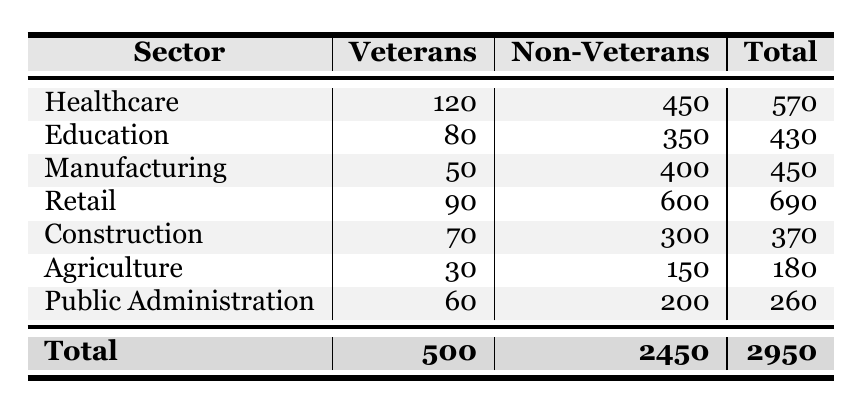What sector has the highest number of veterans employed? According to the table, the sector with the highest number of veterans employed is Healthcare, with 120 veterans employed.
Answer: Healthcare How many total employees (veterans and non-veterans) are there in the Retail sector? The Retail sector has 90 veterans employed and 600 non-veterans employed. Adding these gives a total of 90 + 600 = 690 employees.
Answer: 690 Is there a greater number of non-veterans employed in Agriculture than in Construction? In Agriculture, there are 150 non-veterans employed, while in Construction, there are 300 non-veterans. Since 150 is less than 300, the statement is false.
Answer: No What is the total number of veterans employed across all sectors? To find the total number of veterans employed, sum all the veterans employed in each sector: 120 + 80 + 50 + 90 + 70 + 30 + 60 = 500.
Answer: 500 Which sector has the smallest number of veterans employed, and how many are there? Looking through the table, the Agriculture sector has the smallest number of veterans employed, which is 30.
Answer: Agriculture, 30 What is the average number of veterans employed per sector? There are 7 sectors, and the total number of veterans employed is 500. To find the average, divide the total by the number of sectors: 500 / 7 ≈ 71.43.
Answer: 71.43 Are there more veterans employed in Public Administration than in Education? Public Administration has 60 veterans employed, while Education has 80. Since 60 is less than 80, the statement is false.
Answer: No How many more non-veterans than veterans are employed in the Manufacturing sector? In Manufacturing, there are 50 veterans and 400 non-veterans. To find the difference, subtract the number of veterans from non-veterans: 400 - 50 = 350.
Answer: 350 